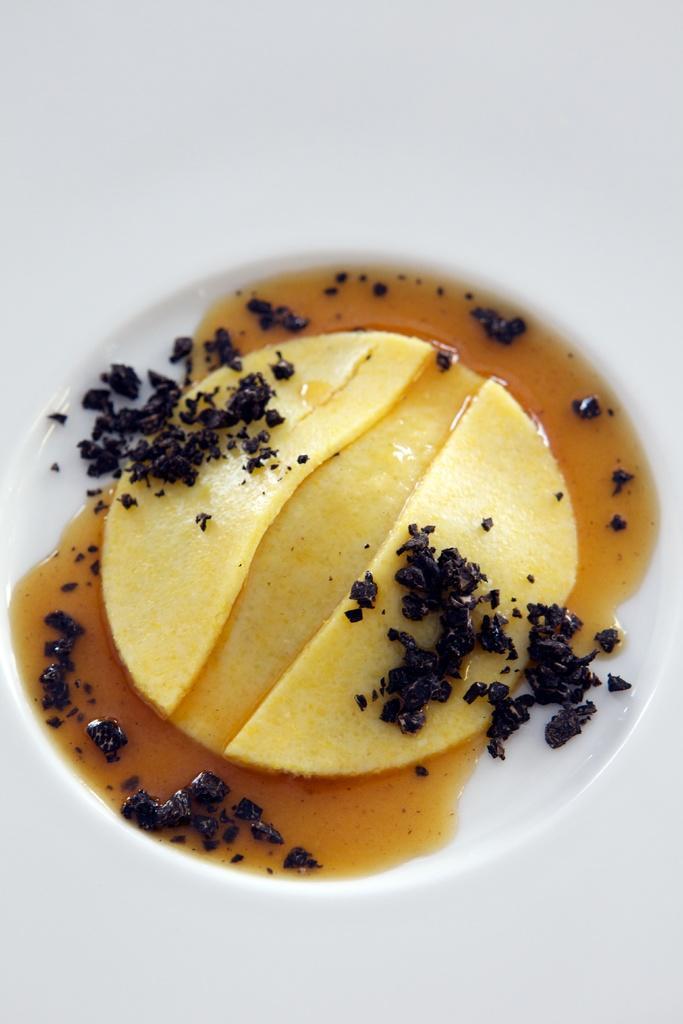How would you summarize this image in a sentence or two? In this image we can see a food item in a plate. 